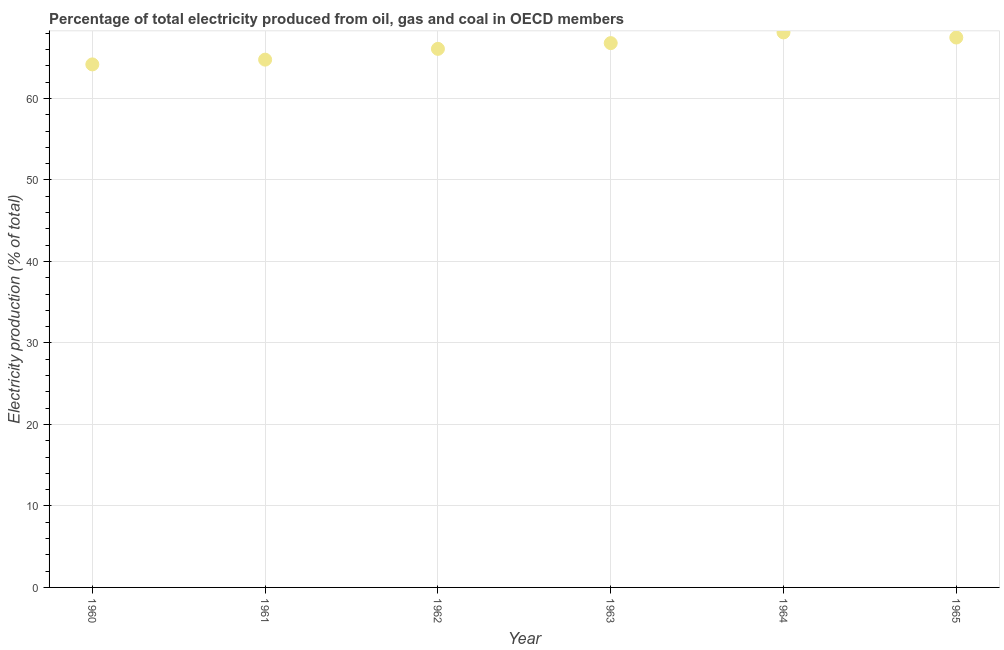What is the electricity production in 1960?
Your answer should be very brief. 64.19. Across all years, what is the maximum electricity production?
Provide a short and direct response. 68.11. Across all years, what is the minimum electricity production?
Ensure brevity in your answer.  64.19. In which year was the electricity production maximum?
Ensure brevity in your answer.  1964. What is the sum of the electricity production?
Offer a very short reply. 397.44. What is the difference between the electricity production in 1960 and 1963?
Give a very brief answer. -2.61. What is the average electricity production per year?
Provide a short and direct response. 66.24. What is the median electricity production?
Your answer should be very brief. 66.45. What is the ratio of the electricity production in 1961 to that in 1965?
Keep it short and to the point. 0.96. What is the difference between the highest and the second highest electricity production?
Make the answer very short. 0.63. Is the sum of the electricity production in 1963 and 1965 greater than the maximum electricity production across all years?
Give a very brief answer. Yes. What is the difference between the highest and the lowest electricity production?
Offer a terse response. 3.92. How many dotlines are there?
Ensure brevity in your answer.  1. How many years are there in the graph?
Your answer should be compact. 6. Does the graph contain any zero values?
Ensure brevity in your answer.  No. Does the graph contain grids?
Ensure brevity in your answer.  Yes. What is the title of the graph?
Give a very brief answer. Percentage of total electricity produced from oil, gas and coal in OECD members. What is the label or title of the X-axis?
Make the answer very short. Year. What is the label or title of the Y-axis?
Offer a terse response. Electricity production (% of total). What is the Electricity production (% of total) in 1960?
Give a very brief answer. 64.19. What is the Electricity production (% of total) in 1961?
Your response must be concise. 64.77. What is the Electricity production (% of total) in 1962?
Provide a short and direct response. 66.09. What is the Electricity production (% of total) in 1963?
Offer a terse response. 66.8. What is the Electricity production (% of total) in 1964?
Give a very brief answer. 68.11. What is the Electricity production (% of total) in 1965?
Your answer should be compact. 67.48. What is the difference between the Electricity production (% of total) in 1960 and 1961?
Provide a short and direct response. -0.58. What is the difference between the Electricity production (% of total) in 1960 and 1962?
Your answer should be compact. -1.91. What is the difference between the Electricity production (% of total) in 1960 and 1963?
Provide a short and direct response. -2.61. What is the difference between the Electricity production (% of total) in 1960 and 1964?
Provide a short and direct response. -3.92. What is the difference between the Electricity production (% of total) in 1960 and 1965?
Offer a terse response. -3.3. What is the difference between the Electricity production (% of total) in 1961 and 1962?
Provide a succinct answer. -1.32. What is the difference between the Electricity production (% of total) in 1961 and 1963?
Your answer should be very brief. -2.03. What is the difference between the Electricity production (% of total) in 1961 and 1964?
Your answer should be compact. -3.34. What is the difference between the Electricity production (% of total) in 1961 and 1965?
Ensure brevity in your answer.  -2.71. What is the difference between the Electricity production (% of total) in 1962 and 1963?
Keep it short and to the point. -0.7. What is the difference between the Electricity production (% of total) in 1962 and 1964?
Offer a very short reply. -2.02. What is the difference between the Electricity production (% of total) in 1962 and 1965?
Your answer should be compact. -1.39. What is the difference between the Electricity production (% of total) in 1963 and 1964?
Offer a terse response. -1.31. What is the difference between the Electricity production (% of total) in 1963 and 1965?
Offer a terse response. -0.69. What is the difference between the Electricity production (% of total) in 1964 and 1965?
Offer a terse response. 0.63. What is the ratio of the Electricity production (% of total) in 1960 to that in 1962?
Give a very brief answer. 0.97. What is the ratio of the Electricity production (% of total) in 1960 to that in 1963?
Keep it short and to the point. 0.96. What is the ratio of the Electricity production (% of total) in 1960 to that in 1964?
Your response must be concise. 0.94. What is the ratio of the Electricity production (% of total) in 1960 to that in 1965?
Make the answer very short. 0.95. What is the ratio of the Electricity production (% of total) in 1961 to that in 1964?
Offer a terse response. 0.95. What is the ratio of the Electricity production (% of total) in 1962 to that in 1964?
Provide a succinct answer. 0.97. What is the ratio of the Electricity production (% of total) in 1963 to that in 1965?
Your answer should be very brief. 0.99. 